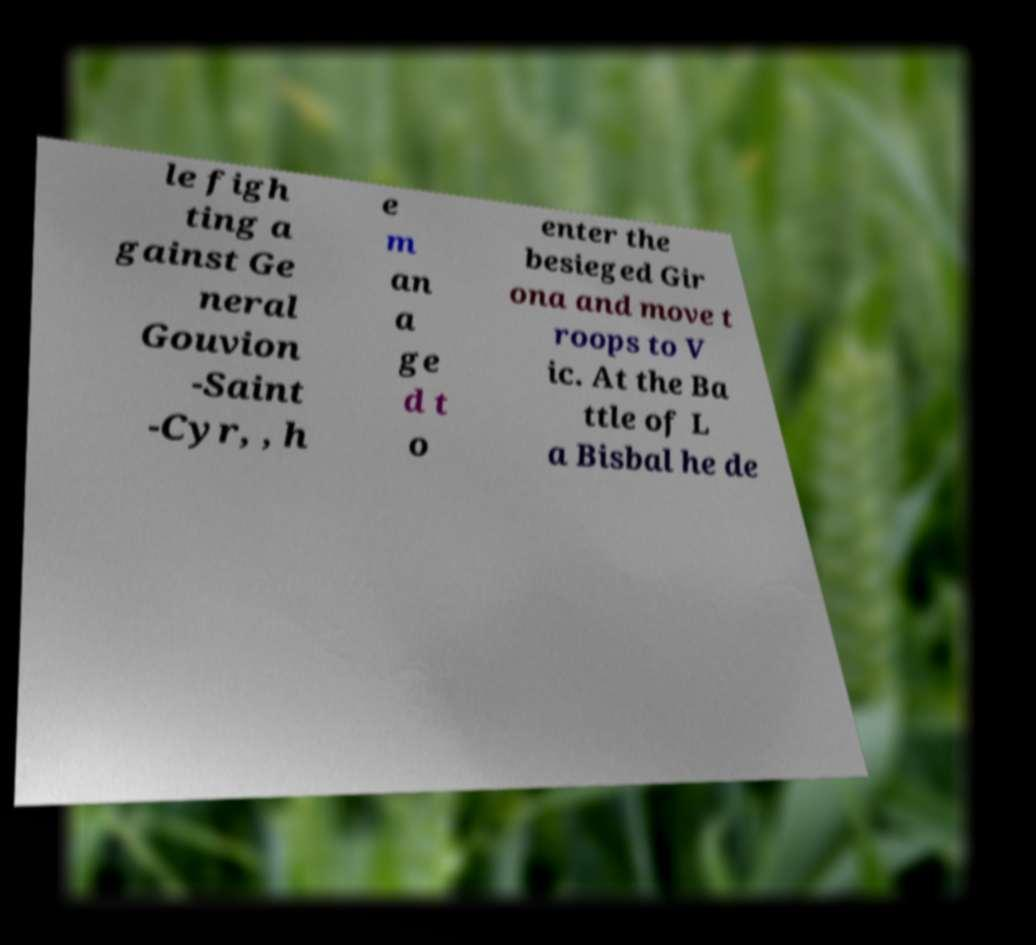Can you accurately transcribe the text from the provided image for me? le figh ting a gainst Ge neral Gouvion -Saint -Cyr, , h e m an a ge d t o enter the besieged Gir ona and move t roops to V ic. At the Ba ttle of L a Bisbal he de 